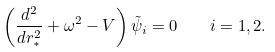<formula> <loc_0><loc_0><loc_500><loc_500>\left ( \frac { d ^ { 2 } } { d r _ { \ast } ^ { 2 } } + \omega ^ { 2 } - V \right ) \tilde { \psi } _ { i } = 0 \quad i = 1 , 2 .</formula> 